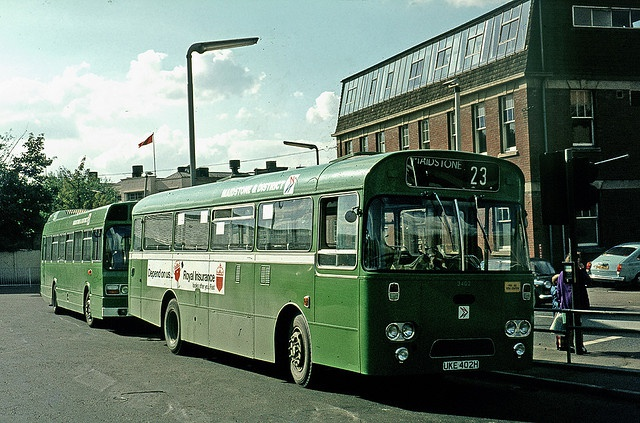Describe the objects in this image and their specific colors. I can see bus in lightblue, black, green, darkgray, and teal tones, bus in lightblue, black, green, teal, and darkgray tones, car in lightblue, black, teal, and darkgray tones, people in lightblue, black, navy, gray, and purple tones, and car in lightblue, black, and teal tones in this image. 